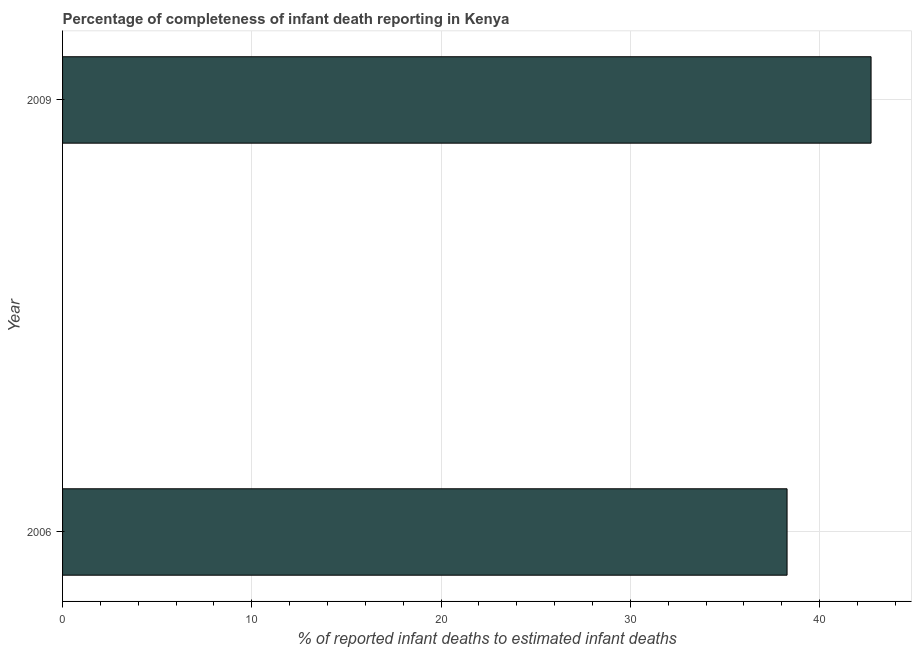Does the graph contain any zero values?
Your answer should be compact. No. Does the graph contain grids?
Provide a succinct answer. Yes. What is the title of the graph?
Give a very brief answer. Percentage of completeness of infant death reporting in Kenya. What is the label or title of the X-axis?
Ensure brevity in your answer.  % of reported infant deaths to estimated infant deaths. What is the completeness of infant death reporting in 2006?
Your response must be concise. 38.28. Across all years, what is the maximum completeness of infant death reporting?
Offer a terse response. 42.71. Across all years, what is the minimum completeness of infant death reporting?
Keep it short and to the point. 38.28. What is the sum of the completeness of infant death reporting?
Offer a very short reply. 80.99. What is the difference between the completeness of infant death reporting in 2006 and 2009?
Provide a short and direct response. -4.44. What is the average completeness of infant death reporting per year?
Your answer should be compact. 40.5. What is the median completeness of infant death reporting?
Offer a terse response. 40.5. In how many years, is the completeness of infant death reporting greater than 6 %?
Offer a very short reply. 2. What is the ratio of the completeness of infant death reporting in 2006 to that in 2009?
Give a very brief answer. 0.9. How many years are there in the graph?
Give a very brief answer. 2. Are the values on the major ticks of X-axis written in scientific E-notation?
Your answer should be very brief. No. What is the % of reported infant deaths to estimated infant deaths of 2006?
Give a very brief answer. 38.28. What is the % of reported infant deaths to estimated infant deaths in 2009?
Your answer should be compact. 42.71. What is the difference between the % of reported infant deaths to estimated infant deaths in 2006 and 2009?
Your answer should be very brief. -4.44. What is the ratio of the % of reported infant deaths to estimated infant deaths in 2006 to that in 2009?
Your answer should be compact. 0.9. 